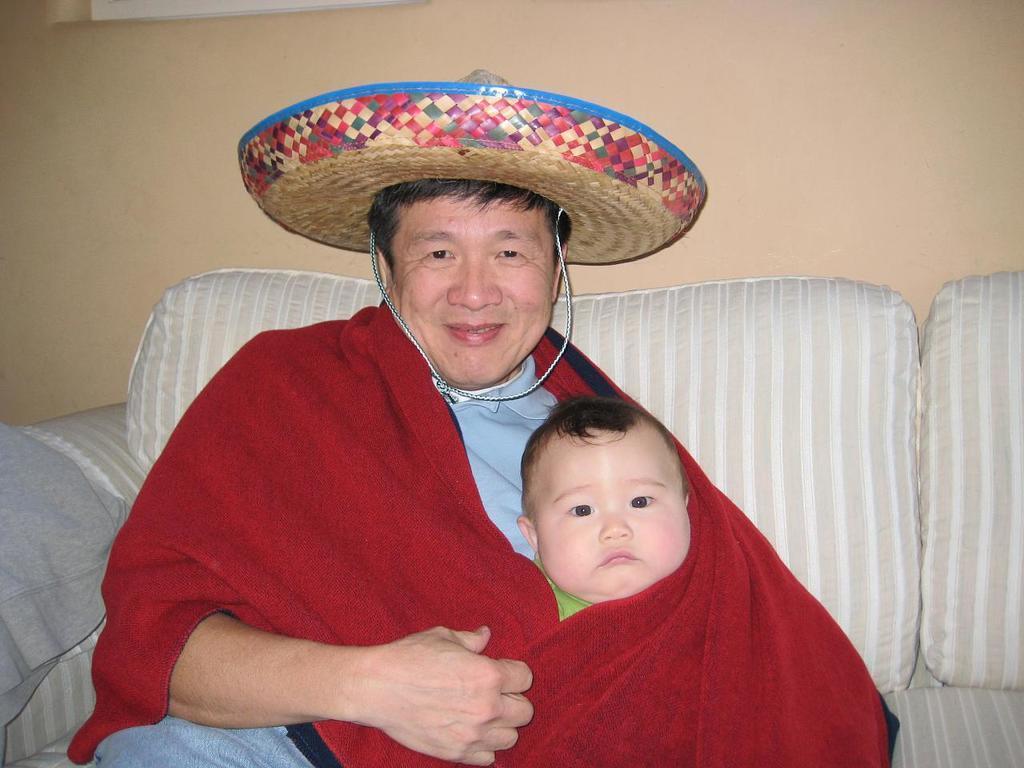Could you give a brief overview of what you see in this image? In this image in front there are two people sitting on the sofa. Behind them there is a wall. 